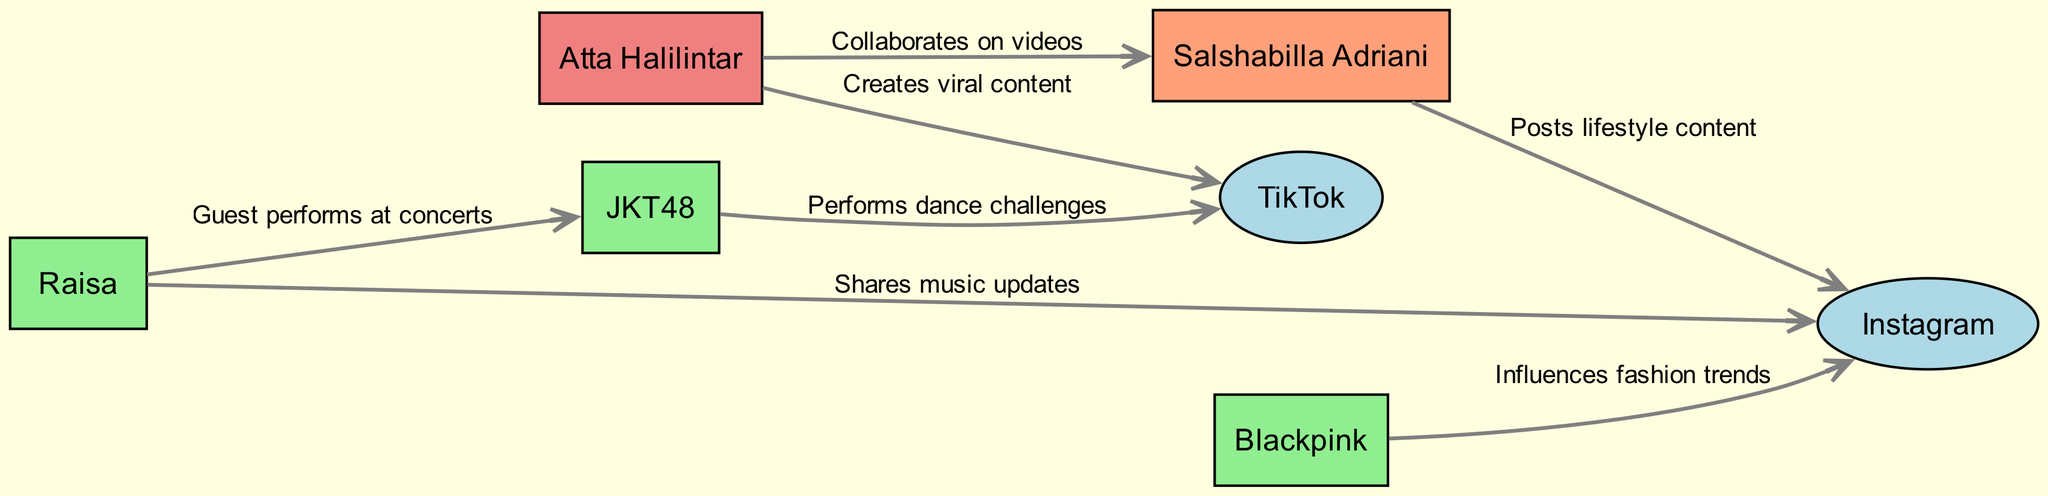What is the total number of nodes in the diagram? The diagram contains nodes representing individuals and social media platforms. By counting, we find there are seven nodes in total: Atta Halilintar, Raisa, Salshabilla Adriani, JKT48, Blackpink, TikTok, and Instagram.
Answer: 7 Which social media platform is connected to Atta Halilintar? The diagram shows an edge going from Atta Halilintar to TikTok, indicating he is connected to this social media platform.
Answer: TikTok How many connections does Raisa have in the diagram? Raisa has two edges connecting her to other nodes, one to Instagram for sharing music updates, and another to JKT48 for guest performances at concerts. Counting these connections shows that she has two connections.
Answer: 2 Who collaborates with Salshabilla Adriani according to the diagram? There is an edge directed from Atta Halilintar to Salshabilla Adriani, indicating a collaboration on videos between these two individuals.
Answer: Atta Halilintar What type of influence does Blackpink have in the diagram? Blackpink influences fashion trends as shown by the edge linking them to Instagram, labeled 'Influences fashion trends.' This specifies the nature of their influence within the entertainment scene.
Answer: Influences fashion trends What is the relationship between JKT48 and TikTok? JKT48 has an edge linking it to TikTok, represented by the label 'Performs dance challenges,' indicating that this idol group engages with TikTok through performance content.
Answer: Performs dance challenges Which two entertainers are connected by a collaboration on videos? The edge in the diagram connects Atta Halilintar and Salshabilla Adriani with the label 'Collaborates on videos,' highlighting their mutual involvement in video content creation.
Answer: Atta Halilintar and Salshabilla Adriani How is TikTok represented in the diagram? TikTok is categorized as a social media platform and depicted as an ellipse, differentiated by its unique fill color (lightblue) among the other nodes depicted as rectangles.
Answer: Social Media Platform 